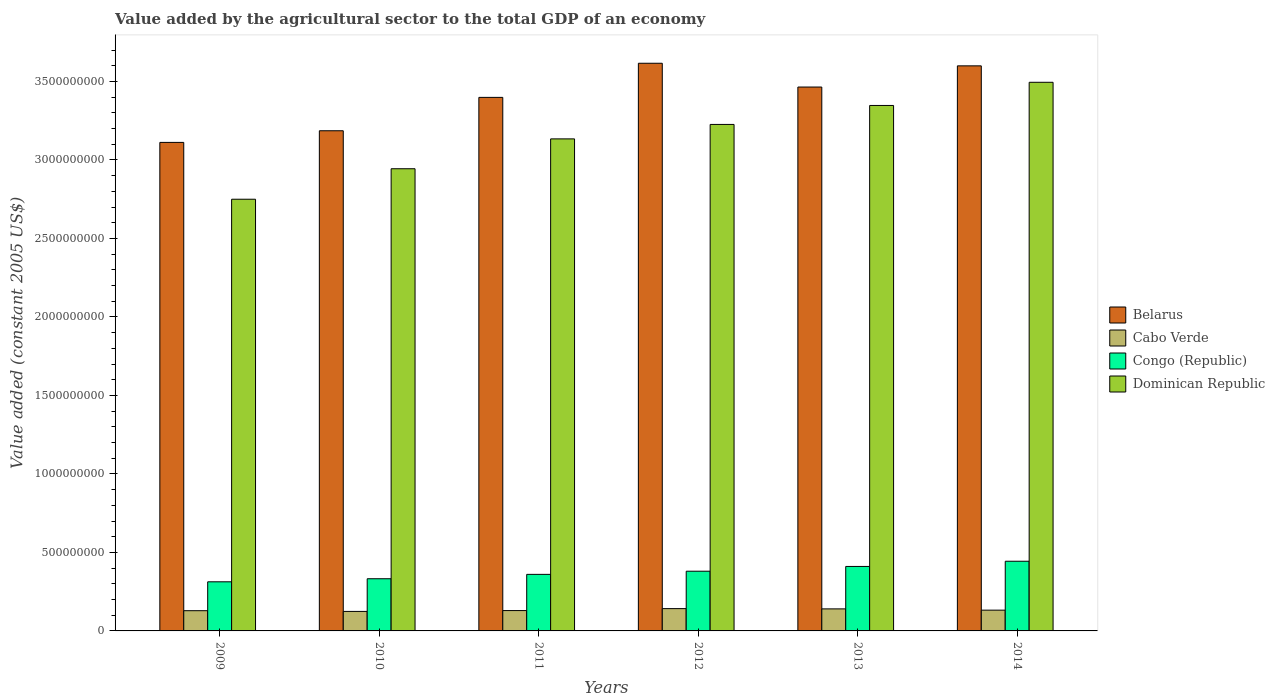How many different coloured bars are there?
Keep it short and to the point. 4. In how many cases, is the number of bars for a given year not equal to the number of legend labels?
Your response must be concise. 0. What is the value added by the agricultural sector in Congo (Republic) in 2010?
Ensure brevity in your answer.  3.32e+08. Across all years, what is the maximum value added by the agricultural sector in Congo (Republic)?
Provide a succinct answer. 4.44e+08. Across all years, what is the minimum value added by the agricultural sector in Belarus?
Your answer should be very brief. 3.11e+09. In which year was the value added by the agricultural sector in Dominican Republic minimum?
Your answer should be compact. 2009. What is the total value added by the agricultural sector in Congo (Republic) in the graph?
Provide a short and direct response. 2.24e+09. What is the difference between the value added by the agricultural sector in Belarus in 2012 and that in 2013?
Offer a terse response. 1.51e+08. What is the difference between the value added by the agricultural sector in Dominican Republic in 2010 and the value added by the agricultural sector in Congo (Republic) in 2013?
Your response must be concise. 2.53e+09. What is the average value added by the agricultural sector in Belarus per year?
Your answer should be compact. 3.40e+09. In the year 2011, what is the difference between the value added by the agricultural sector in Congo (Republic) and value added by the agricultural sector in Cabo Verde?
Ensure brevity in your answer.  2.31e+08. What is the ratio of the value added by the agricultural sector in Cabo Verde in 2012 to that in 2013?
Provide a succinct answer. 1.01. Is the value added by the agricultural sector in Dominican Republic in 2012 less than that in 2014?
Your answer should be compact. Yes. Is the difference between the value added by the agricultural sector in Congo (Republic) in 2011 and 2012 greater than the difference between the value added by the agricultural sector in Cabo Verde in 2011 and 2012?
Ensure brevity in your answer.  No. What is the difference between the highest and the second highest value added by the agricultural sector in Congo (Republic)?
Make the answer very short. 3.31e+07. What is the difference between the highest and the lowest value added by the agricultural sector in Belarus?
Give a very brief answer. 5.04e+08. In how many years, is the value added by the agricultural sector in Congo (Republic) greater than the average value added by the agricultural sector in Congo (Republic) taken over all years?
Provide a short and direct response. 3. Is the sum of the value added by the agricultural sector in Cabo Verde in 2011 and 2014 greater than the maximum value added by the agricultural sector in Congo (Republic) across all years?
Ensure brevity in your answer.  No. Is it the case that in every year, the sum of the value added by the agricultural sector in Cabo Verde and value added by the agricultural sector in Dominican Republic is greater than the sum of value added by the agricultural sector in Congo (Republic) and value added by the agricultural sector in Belarus?
Offer a very short reply. Yes. What does the 2nd bar from the left in 2014 represents?
Give a very brief answer. Cabo Verde. What does the 2nd bar from the right in 2010 represents?
Provide a short and direct response. Congo (Republic). Is it the case that in every year, the sum of the value added by the agricultural sector in Belarus and value added by the agricultural sector in Congo (Republic) is greater than the value added by the agricultural sector in Cabo Verde?
Your answer should be compact. Yes. How many years are there in the graph?
Provide a succinct answer. 6. Are the values on the major ticks of Y-axis written in scientific E-notation?
Provide a succinct answer. No. How many legend labels are there?
Your answer should be compact. 4. How are the legend labels stacked?
Offer a very short reply. Vertical. What is the title of the graph?
Provide a succinct answer. Value added by the agricultural sector to the total GDP of an economy. Does "Tanzania" appear as one of the legend labels in the graph?
Offer a very short reply. No. What is the label or title of the X-axis?
Keep it short and to the point. Years. What is the label or title of the Y-axis?
Your answer should be very brief. Value added (constant 2005 US$). What is the Value added (constant 2005 US$) in Belarus in 2009?
Your answer should be compact. 3.11e+09. What is the Value added (constant 2005 US$) in Cabo Verde in 2009?
Make the answer very short. 1.29e+08. What is the Value added (constant 2005 US$) in Congo (Republic) in 2009?
Keep it short and to the point. 3.13e+08. What is the Value added (constant 2005 US$) of Dominican Republic in 2009?
Ensure brevity in your answer.  2.75e+09. What is the Value added (constant 2005 US$) of Belarus in 2010?
Offer a very short reply. 3.19e+09. What is the Value added (constant 2005 US$) in Cabo Verde in 2010?
Offer a very short reply. 1.24e+08. What is the Value added (constant 2005 US$) of Congo (Republic) in 2010?
Ensure brevity in your answer.  3.32e+08. What is the Value added (constant 2005 US$) of Dominican Republic in 2010?
Provide a succinct answer. 2.94e+09. What is the Value added (constant 2005 US$) of Belarus in 2011?
Provide a succinct answer. 3.40e+09. What is the Value added (constant 2005 US$) of Cabo Verde in 2011?
Your answer should be very brief. 1.30e+08. What is the Value added (constant 2005 US$) in Congo (Republic) in 2011?
Keep it short and to the point. 3.60e+08. What is the Value added (constant 2005 US$) of Dominican Republic in 2011?
Your response must be concise. 3.13e+09. What is the Value added (constant 2005 US$) of Belarus in 2012?
Offer a very short reply. 3.62e+09. What is the Value added (constant 2005 US$) of Cabo Verde in 2012?
Your response must be concise. 1.42e+08. What is the Value added (constant 2005 US$) in Congo (Republic) in 2012?
Give a very brief answer. 3.80e+08. What is the Value added (constant 2005 US$) in Dominican Republic in 2012?
Your answer should be compact. 3.23e+09. What is the Value added (constant 2005 US$) of Belarus in 2013?
Offer a very short reply. 3.46e+09. What is the Value added (constant 2005 US$) in Cabo Verde in 2013?
Keep it short and to the point. 1.40e+08. What is the Value added (constant 2005 US$) in Congo (Republic) in 2013?
Offer a very short reply. 4.11e+08. What is the Value added (constant 2005 US$) of Dominican Republic in 2013?
Your answer should be very brief. 3.35e+09. What is the Value added (constant 2005 US$) in Belarus in 2014?
Make the answer very short. 3.60e+09. What is the Value added (constant 2005 US$) in Cabo Verde in 2014?
Keep it short and to the point. 1.32e+08. What is the Value added (constant 2005 US$) of Congo (Republic) in 2014?
Provide a short and direct response. 4.44e+08. What is the Value added (constant 2005 US$) in Dominican Republic in 2014?
Offer a terse response. 3.49e+09. Across all years, what is the maximum Value added (constant 2005 US$) of Belarus?
Ensure brevity in your answer.  3.62e+09. Across all years, what is the maximum Value added (constant 2005 US$) in Cabo Verde?
Your answer should be compact. 1.42e+08. Across all years, what is the maximum Value added (constant 2005 US$) in Congo (Republic)?
Make the answer very short. 4.44e+08. Across all years, what is the maximum Value added (constant 2005 US$) in Dominican Republic?
Your response must be concise. 3.49e+09. Across all years, what is the minimum Value added (constant 2005 US$) in Belarus?
Provide a succinct answer. 3.11e+09. Across all years, what is the minimum Value added (constant 2005 US$) of Cabo Verde?
Provide a short and direct response. 1.24e+08. Across all years, what is the minimum Value added (constant 2005 US$) in Congo (Republic)?
Make the answer very short. 3.13e+08. Across all years, what is the minimum Value added (constant 2005 US$) in Dominican Republic?
Your answer should be compact. 2.75e+09. What is the total Value added (constant 2005 US$) in Belarus in the graph?
Give a very brief answer. 2.04e+1. What is the total Value added (constant 2005 US$) in Cabo Verde in the graph?
Keep it short and to the point. 7.98e+08. What is the total Value added (constant 2005 US$) in Congo (Republic) in the graph?
Give a very brief answer. 2.24e+09. What is the total Value added (constant 2005 US$) in Dominican Republic in the graph?
Offer a terse response. 1.89e+1. What is the difference between the Value added (constant 2005 US$) of Belarus in 2009 and that in 2010?
Offer a very short reply. -7.41e+07. What is the difference between the Value added (constant 2005 US$) in Cabo Verde in 2009 and that in 2010?
Ensure brevity in your answer.  4.67e+06. What is the difference between the Value added (constant 2005 US$) in Congo (Republic) in 2009 and that in 2010?
Offer a very short reply. -1.96e+07. What is the difference between the Value added (constant 2005 US$) of Dominican Republic in 2009 and that in 2010?
Your answer should be compact. -1.94e+08. What is the difference between the Value added (constant 2005 US$) of Belarus in 2009 and that in 2011?
Offer a terse response. -2.87e+08. What is the difference between the Value added (constant 2005 US$) in Cabo Verde in 2009 and that in 2011?
Your answer should be compact. -7.68e+05. What is the difference between the Value added (constant 2005 US$) of Congo (Republic) in 2009 and that in 2011?
Make the answer very short. -4.75e+07. What is the difference between the Value added (constant 2005 US$) in Dominican Republic in 2009 and that in 2011?
Keep it short and to the point. -3.84e+08. What is the difference between the Value added (constant 2005 US$) of Belarus in 2009 and that in 2012?
Your answer should be very brief. -5.04e+08. What is the difference between the Value added (constant 2005 US$) of Cabo Verde in 2009 and that in 2012?
Provide a short and direct response. -1.32e+07. What is the difference between the Value added (constant 2005 US$) of Congo (Republic) in 2009 and that in 2012?
Offer a very short reply. -6.75e+07. What is the difference between the Value added (constant 2005 US$) of Dominican Republic in 2009 and that in 2012?
Offer a very short reply. -4.76e+08. What is the difference between the Value added (constant 2005 US$) of Belarus in 2009 and that in 2013?
Provide a succinct answer. -3.53e+08. What is the difference between the Value added (constant 2005 US$) in Cabo Verde in 2009 and that in 2013?
Make the answer very short. -1.15e+07. What is the difference between the Value added (constant 2005 US$) in Congo (Republic) in 2009 and that in 2013?
Offer a very short reply. -9.79e+07. What is the difference between the Value added (constant 2005 US$) of Dominican Republic in 2009 and that in 2013?
Your answer should be very brief. -5.97e+08. What is the difference between the Value added (constant 2005 US$) in Belarus in 2009 and that in 2014?
Ensure brevity in your answer.  -4.88e+08. What is the difference between the Value added (constant 2005 US$) of Cabo Verde in 2009 and that in 2014?
Offer a very short reply. -3.41e+06. What is the difference between the Value added (constant 2005 US$) of Congo (Republic) in 2009 and that in 2014?
Ensure brevity in your answer.  -1.31e+08. What is the difference between the Value added (constant 2005 US$) in Dominican Republic in 2009 and that in 2014?
Give a very brief answer. -7.45e+08. What is the difference between the Value added (constant 2005 US$) in Belarus in 2010 and that in 2011?
Provide a short and direct response. -2.13e+08. What is the difference between the Value added (constant 2005 US$) in Cabo Verde in 2010 and that in 2011?
Your response must be concise. -5.44e+06. What is the difference between the Value added (constant 2005 US$) in Congo (Republic) in 2010 and that in 2011?
Keep it short and to the point. -2.79e+07. What is the difference between the Value added (constant 2005 US$) of Dominican Republic in 2010 and that in 2011?
Provide a succinct answer. -1.90e+08. What is the difference between the Value added (constant 2005 US$) in Belarus in 2010 and that in 2012?
Give a very brief answer. -4.30e+08. What is the difference between the Value added (constant 2005 US$) of Cabo Verde in 2010 and that in 2012?
Provide a short and direct response. -1.79e+07. What is the difference between the Value added (constant 2005 US$) in Congo (Republic) in 2010 and that in 2012?
Offer a very short reply. -4.79e+07. What is the difference between the Value added (constant 2005 US$) in Dominican Republic in 2010 and that in 2012?
Provide a succinct answer. -2.82e+08. What is the difference between the Value added (constant 2005 US$) in Belarus in 2010 and that in 2013?
Your answer should be compact. -2.79e+08. What is the difference between the Value added (constant 2005 US$) of Cabo Verde in 2010 and that in 2013?
Your answer should be compact. -1.61e+07. What is the difference between the Value added (constant 2005 US$) in Congo (Republic) in 2010 and that in 2013?
Make the answer very short. -7.83e+07. What is the difference between the Value added (constant 2005 US$) in Dominican Republic in 2010 and that in 2013?
Keep it short and to the point. -4.03e+08. What is the difference between the Value added (constant 2005 US$) of Belarus in 2010 and that in 2014?
Offer a very short reply. -4.13e+08. What is the difference between the Value added (constant 2005 US$) in Cabo Verde in 2010 and that in 2014?
Your response must be concise. -8.08e+06. What is the difference between the Value added (constant 2005 US$) of Congo (Republic) in 2010 and that in 2014?
Give a very brief answer. -1.11e+08. What is the difference between the Value added (constant 2005 US$) of Dominican Republic in 2010 and that in 2014?
Provide a succinct answer. -5.51e+08. What is the difference between the Value added (constant 2005 US$) of Belarus in 2011 and that in 2012?
Make the answer very short. -2.17e+08. What is the difference between the Value added (constant 2005 US$) in Cabo Verde in 2011 and that in 2012?
Provide a short and direct response. -1.24e+07. What is the difference between the Value added (constant 2005 US$) in Congo (Republic) in 2011 and that in 2012?
Provide a short and direct response. -2.00e+07. What is the difference between the Value added (constant 2005 US$) in Dominican Republic in 2011 and that in 2012?
Ensure brevity in your answer.  -9.20e+07. What is the difference between the Value added (constant 2005 US$) in Belarus in 2011 and that in 2013?
Provide a succinct answer. -6.59e+07. What is the difference between the Value added (constant 2005 US$) of Cabo Verde in 2011 and that in 2013?
Give a very brief answer. -1.07e+07. What is the difference between the Value added (constant 2005 US$) in Congo (Republic) in 2011 and that in 2013?
Provide a succinct answer. -5.04e+07. What is the difference between the Value added (constant 2005 US$) of Dominican Republic in 2011 and that in 2013?
Provide a short and direct response. -2.13e+08. What is the difference between the Value added (constant 2005 US$) of Belarus in 2011 and that in 2014?
Ensure brevity in your answer.  -2.01e+08. What is the difference between the Value added (constant 2005 US$) of Cabo Verde in 2011 and that in 2014?
Your answer should be compact. -2.64e+06. What is the difference between the Value added (constant 2005 US$) in Congo (Republic) in 2011 and that in 2014?
Your answer should be compact. -8.36e+07. What is the difference between the Value added (constant 2005 US$) of Dominican Republic in 2011 and that in 2014?
Give a very brief answer. -3.60e+08. What is the difference between the Value added (constant 2005 US$) in Belarus in 2012 and that in 2013?
Ensure brevity in your answer.  1.51e+08. What is the difference between the Value added (constant 2005 US$) of Cabo Verde in 2012 and that in 2013?
Give a very brief answer. 1.72e+06. What is the difference between the Value added (constant 2005 US$) of Congo (Republic) in 2012 and that in 2013?
Give a very brief answer. -3.04e+07. What is the difference between the Value added (constant 2005 US$) of Dominican Republic in 2012 and that in 2013?
Offer a terse response. -1.21e+08. What is the difference between the Value added (constant 2005 US$) in Belarus in 2012 and that in 2014?
Offer a terse response. 1.66e+07. What is the difference between the Value added (constant 2005 US$) of Cabo Verde in 2012 and that in 2014?
Keep it short and to the point. 9.78e+06. What is the difference between the Value added (constant 2005 US$) of Congo (Republic) in 2012 and that in 2014?
Your answer should be compact. -6.35e+07. What is the difference between the Value added (constant 2005 US$) in Dominican Republic in 2012 and that in 2014?
Your response must be concise. -2.68e+08. What is the difference between the Value added (constant 2005 US$) in Belarus in 2013 and that in 2014?
Ensure brevity in your answer.  -1.35e+08. What is the difference between the Value added (constant 2005 US$) in Cabo Verde in 2013 and that in 2014?
Your answer should be compact. 8.06e+06. What is the difference between the Value added (constant 2005 US$) in Congo (Republic) in 2013 and that in 2014?
Your response must be concise. -3.31e+07. What is the difference between the Value added (constant 2005 US$) in Dominican Republic in 2013 and that in 2014?
Keep it short and to the point. -1.48e+08. What is the difference between the Value added (constant 2005 US$) in Belarus in 2009 and the Value added (constant 2005 US$) in Cabo Verde in 2010?
Offer a terse response. 2.99e+09. What is the difference between the Value added (constant 2005 US$) of Belarus in 2009 and the Value added (constant 2005 US$) of Congo (Republic) in 2010?
Keep it short and to the point. 2.78e+09. What is the difference between the Value added (constant 2005 US$) of Belarus in 2009 and the Value added (constant 2005 US$) of Dominican Republic in 2010?
Offer a very short reply. 1.68e+08. What is the difference between the Value added (constant 2005 US$) in Cabo Verde in 2009 and the Value added (constant 2005 US$) in Congo (Republic) in 2010?
Provide a short and direct response. -2.04e+08. What is the difference between the Value added (constant 2005 US$) in Cabo Verde in 2009 and the Value added (constant 2005 US$) in Dominican Republic in 2010?
Give a very brief answer. -2.82e+09. What is the difference between the Value added (constant 2005 US$) in Congo (Republic) in 2009 and the Value added (constant 2005 US$) in Dominican Republic in 2010?
Ensure brevity in your answer.  -2.63e+09. What is the difference between the Value added (constant 2005 US$) of Belarus in 2009 and the Value added (constant 2005 US$) of Cabo Verde in 2011?
Offer a terse response. 2.98e+09. What is the difference between the Value added (constant 2005 US$) of Belarus in 2009 and the Value added (constant 2005 US$) of Congo (Republic) in 2011?
Make the answer very short. 2.75e+09. What is the difference between the Value added (constant 2005 US$) of Belarus in 2009 and the Value added (constant 2005 US$) of Dominican Republic in 2011?
Your answer should be very brief. -2.24e+07. What is the difference between the Value added (constant 2005 US$) of Cabo Verde in 2009 and the Value added (constant 2005 US$) of Congo (Republic) in 2011?
Provide a short and direct response. -2.31e+08. What is the difference between the Value added (constant 2005 US$) in Cabo Verde in 2009 and the Value added (constant 2005 US$) in Dominican Republic in 2011?
Keep it short and to the point. -3.01e+09. What is the difference between the Value added (constant 2005 US$) in Congo (Republic) in 2009 and the Value added (constant 2005 US$) in Dominican Republic in 2011?
Ensure brevity in your answer.  -2.82e+09. What is the difference between the Value added (constant 2005 US$) in Belarus in 2009 and the Value added (constant 2005 US$) in Cabo Verde in 2012?
Your response must be concise. 2.97e+09. What is the difference between the Value added (constant 2005 US$) in Belarus in 2009 and the Value added (constant 2005 US$) in Congo (Republic) in 2012?
Give a very brief answer. 2.73e+09. What is the difference between the Value added (constant 2005 US$) in Belarus in 2009 and the Value added (constant 2005 US$) in Dominican Republic in 2012?
Your answer should be compact. -1.14e+08. What is the difference between the Value added (constant 2005 US$) of Cabo Verde in 2009 and the Value added (constant 2005 US$) of Congo (Republic) in 2012?
Your answer should be compact. -2.51e+08. What is the difference between the Value added (constant 2005 US$) of Cabo Verde in 2009 and the Value added (constant 2005 US$) of Dominican Republic in 2012?
Provide a short and direct response. -3.10e+09. What is the difference between the Value added (constant 2005 US$) of Congo (Republic) in 2009 and the Value added (constant 2005 US$) of Dominican Republic in 2012?
Ensure brevity in your answer.  -2.91e+09. What is the difference between the Value added (constant 2005 US$) in Belarus in 2009 and the Value added (constant 2005 US$) in Cabo Verde in 2013?
Provide a succinct answer. 2.97e+09. What is the difference between the Value added (constant 2005 US$) of Belarus in 2009 and the Value added (constant 2005 US$) of Congo (Republic) in 2013?
Make the answer very short. 2.70e+09. What is the difference between the Value added (constant 2005 US$) of Belarus in 2009 and the Value added (constant 2005 US$) of Dominican Republic in 2013?
Offer a terse response. -2.35e+08. What is the difference between the Value added (constant 2005 US$) of Cabo Verde in 2009 and the Value added (constant 2005 US$) of Congo (Republic) in 2013?
Your answer should be compact. -2.82e+08. What is the difference between the Value added (constant 2005 US$) in Cabo Verde in 2009 and the Value added (constant 2005 US$) in Dominican Republic in 2013?
Ensure brevity in your answer.  -3.22e+09. What is the difference between the Value added (constant 2005 US$) of Congo (Republic) in 2009 and the Value added (constant 2005 US$) of Dominican Republic in 2013?
Offer a very short reply. -3.03e+09. What is the difference between the Value added (constant 2005 US$) in Belarus in 2009 and the Value added (constant 2005 US$) in Cabo Verde in 2014?
Give a very brief answer. 2.98e+09. What is the difference between the Value added (constant 2005 US$) of Belarus in 2009 and the Value added (constant 2005 US$) of Congo (Republic) in 2014?
Provide a succinct answer. 2.67e+09. What is the difference between the Value added (constant 2005 US$) of Belarus in 2009 and the Value added (constant 2005 US$) of Dominican Republic in 2014?
Provide a short and direct response. -3.83e+08. What is the difference between the Value added (constant 2005 US$) of Cabo Verde in 2009 and the Value added (constant 2005 US$) of Congo (Republic) in 2014?
Keep it short and to the point. -3.15e+08. What is the difference between the Value added (constant 2005 US$) in Cabo Verde in 2009 and the Value added (constant 2005 US$) in Dominican Republic in 2014?
Your answer should be compact. -3.37e+09. What is the difference between the Value added (constant 2005 US$) in Congo (Republic) in 2009 and the Value added (constant 2005 US$) in Dominican Republic in 2014?
Offer a very short reply. -3.18e+09. What is the difference between the Value added (constant 2005 US$) in Belarus in 2010 and the Value added (constant 2005 US$) in Cabo Verde in 2011?
Keep it short and to the point. 3.06e+09. What is the difference between the Value added (constant 2005 US$) in Belarus in 2010 and the Value added (constant 2005 US$) in Congo (Republic) in 2011?
Your answer should be very brief. 2.83e+09. What is the difference between the Value added (constant 2005 US$) in Belarus in 2010 and the Value added (constant 2005 US$) in Dominican Republic in 2011?
Your answer should be very brief. 5.17e+07. What is the difference between the Value added (constant 2005 US$) of Cabo Verde in 2010 and the Value added (constant 2005 US$) of Congo (Republic) in 2011?
Offer a terse response. -2.36e+08. What is the difference between the Value added (constant 2005 US$) of Cabo Verde in 2010 and the Value added (constant 2005 US$) of Dominican Republic in 2011?
Make the answer very short. -3.01e+09. What is the difference between the Value added (constant 2005 US$) of Congo (Republic) in 2010 and the Value added (constant 2005 US$) of Dominican Republic in 2011?
Your response must be concise. -2.80e+09. What is the difference between the Value added (constant 2005 US$) in Belarus in 2010 and the Value added (constant 2005 US$) in Cabo Verde in 2012?
Ensure brevity in your answer.  3.04e+09. What is the difference between the Value added (constant 2005 US$) in Belarus in 2010 and the Value added (constant 2005 US$) in Congo (Republic) in 2012?
Keep it short and to the point. 2.81e+09. What is the difference between the Value added (constant 2005 US$) of Belarus in 2010 and the Value added (constant 2005 US$) of Dominican Republic in 2012?
Provide a short and direct response. -4.03e+07. What is the difference between the Value added (constant 2005 US$) of Cabo Verde in 2010 and the Value added (constant 2005 US$) of Congo (Republic) in 2012?
Make the answer very short. -2.56e+08. What is the difference between the Value added (constant 2005 US$) of Cabo Verde in 2010 and the Value added (constant 2005 US$) of Dominican Republic in 2012?
Ensure brevity in your answer.  -3.10e+09. What is the difference between the Value added (constant 2005 US$) in Congo (Republic) in 2010 and the Value added (constant 2005 US$) in Dominican Republic in 2012?
Your answer should be compact. -2.89e+09. What is the difference between the Value added (constant 2005 US$) in Belarus in 2010 and the Value added (constant 2005 US$) in Cabo Verde in 2013?
Your response must be concise. 3.05e+09. What is the difference between the Value added (constant 2005 US$) in Belarus in 2010 and the Value added (constant 2005 US$) in Congo (Republic) in 2013?
Offer a terse response. 2.78e+09. What is the difference between the Value added (constant 2005 US$) of Belarus in 2010 and the Value added (constant 2005 US$) of Dominican Republic in 2013?
Provide a succinct answer. -1.61e+08. What is the difference between the Value added (constant 2005 US$) of Cabo Verde in 2010 and the Value added (constant 2005 US$) of Congo (Republic) in 2013?
Offer a very short reply. -2.87e+08. What is the difference between the Value added (constant 2005 US$) in Cabo Verde in 2010 and the Value added (constant 2005 US$) in Dominican Republic in 2013?
Your answer should be compact. -3.22e+09. What is the difference between the Value added (constant 2005 US$) in Congo (Republic) in 2010 and the Value added (constant 2005 US$) in Dominican Republic in 2013?
Your response must be concise. -3.01e+09. What is the difference between the Value added (constant 2005 US$) of Belarus in 2010 and the Value added (constant 2005 US$) of Cabo Verde in 2014?
Keep it short and to the point. 3.05e+09. What is the difference between the Value added (constant 2005 US$) of Belarus in 2010 and the Value added (constant 2005 US$) of Congo (Republic) in 2014?
Your answer should be very brief. 2.74e+09. What is the difference between the Value added (constant 2005 US$) of Belarus in 2010 and the Value added (constant 2005 US$) of Dominican Republic in 2014?
Your response must be concise. -3.09e+08. What is the difference between the Value added (constant 2005 US$) in Cabo Verde in 2010 and the Value added (constant 2005 US$) in Congo (Republic) in 2014?
Your answer should be compact. -3.20e+08. What is the difference between the Value added (constant 2005 US$) of Cabo Verde in 2010 and the Value added (constant 2005 US$) of Dominican Republic in 2014?
Your answer should be very brief. -3.37e+09. What is the difference between the Value added (constant 2005 US$) in Congo (Republic) in 2010 and the Value added (constant 2005 US$) in Dominican Republic in 2014?
Your response must be concise. -3.16e+09. What is the difference between the Value added (constant 2005 US$) in Belarus in 2011 and the Value added (constant 2005 US$) in Cabo Verde in 2012?
Your response must be concise. 3.26e+09. What is the difference between the Value added (constant 2005 US$) of Belarus in 2011 and the Value added (constant 2005 US$) of Congo (Republic) in 2012?
Your response must be concise. 3.02e+09. What is the difference between the Value added (constant 2005 US$) in Belarus in 2011 and the Value added (constant 2005 US$) in Dominican Republic in 2012?
Ensure brevity in your answer.  1.72e+08. What is the difference between the Value added (constant 2005 US$) in Cabo Verde in 2011 and the Value added (constant 2005 US$) in Congo (Republic) in 2012?
Ensure brevity in your answer.  -2.51e+08. What is the difference between the Value added (constant 2005 US$) in Cabo Verde in 2011 and the Value added (constant 2005 US$) in Dominican Republic in 2012?
Make the answer very short. -3.10e+09. What is the difference between the Value added (constant 2005 US$) in Congo (Republic) in 2011 and the Value added (constant 2005 US$) in Dominican Republic in 2012?
Provide a succinct answer. -2.87e+09. What is the difference between the Value added (constant 2005 US$) in Belarus in 2011 and the Value added (constant 2005 US$) in Cabo Verde in 2013?
Provide a succinct answer. 3.26e+09. What is the difference between the Value added (constant 2005 US$) of Belarus in 2011 and the Value added (constant 2005 US$) of Congo (Republic) in 2013?
Provide a short and direct response. 2.99e+09. What is the difference between the Value added (constant 2005 US$) in Belarus in 2011 and the Value added (constant 2005 US$) in Dominican Republic in 2013?
Make the answer very short. 5.15e+07. What is the difference between the Value added (constant 2005 US$) in Cabo Verde in 2011 and the Value added (constant 2005 US$) in Congo (Republic) in 2013?
Your answer should be very brief. -2.81e+08. What is the difference between the Value added (constant 2005 US$) of Cabo Verde in 2011 and the Value added (constant 2005 US$) of Dominican Republic in 2013?
Keep it short and to the point. -3.22e+09. What is the difference between the Value added (constant 2005 US$) of Congo (Republic) in 2011 and the Value added (constant 2005 US$) of Dominican Republic in 2013?
Provide a succinct answer. -2.99e+09. What is the difference between the Value added (constant 2005 US$) in Belarus in 2011 and the Value added (constant 2005 US$) in Cabo Verde in 2014?
Your response must be concise. 3.27e+09. What is the difference between the Value added (constant 2005 US$) in Belarus in 2011 and the Value added (constant 2005 US$) in Congo (Republic) in 2014?
Ensure brevity in your answer.  2.95e+09. What is the difference between the Value added (constant 2005 US$) of Belarus in 2011 and the Value added (constant 2005 US$) of Dominican Republic in 2014?
Your answer should be very brief. -9.61e+07. What is the difference between the Value added (constant 2005 US$) in Cabo Verde in 2011 and the Value added (constant 2005 US$) in Congo (Republic) in 2014?
Provide a succinct answer. -3.14e+08. What is the difference between the Value added (constant 2005 US$) of Cabo Verde in 2011 and the Value added (constant 2005 US$) of Dominican Republic in 2014?
Provide a short and direct response. -3.37e+09. What is the difference between the Value added (constant 2005 US$) in Congo (Republic) in 2011 and the Value added (constant 2005 US$) in Dominican Republic in 2014?
Your response must be concise. -3.13e+09. What is the difference between the Value added (constant 2005 US$) in Belarus in 2012 and the Value added (constant 2005 US$) in Cabo Verde in 2013?
Offer a terse response. 3.48e+09. What is the difference between the Value added (constant 2005 US$) of Belarus in 2012 and the Value added (constant 2005 US$) of Congo (Republic) in 2013?
Your answer should be compact. 3.21e+09. What is the difference between the Value added (constant 2005 US$) of Belarus in 2012 and the Value added (constant 2005 US$) of Dominican Republic in 2013?
Your response must be concise. 2.69e+08. What is the difference between the Value added (constant 2005 US$) of Cabo Verde in 2012 and the Value added (constant 2005 US$) of Congo (Republic) in 2013?
Provide a succinct answer. -2.69e+08. What is the difference between the Value added (constant 2005 US$) of Cabo Verde in 2012 and the Value added (constant 2005 US$) of Dominican Republic in 2013?
Make the answer very short. -3.21e+09. What is the difference between the Value added (constant 2005 US$) in Congo (Republic) in 2012 and the Value added (constant 2005 US$) in Dominican Republic in 2013?
Give a very brief answer. -2.97e+09. What is the difference between the Value added (constant 2005 US$) in Belarus in 2012 and the Value added (constant 2005 US$) in Cabo Verde in 2014?
Your answer should be very brief. 3.48e+09. What is the difference between the Value added (constant 2005 US$) of Belarus in 2012 and the Value added (constant 2005 US$) of Congo (Republic) in 2014?
Your answer should be compact. 3.17e+09. What is the difference between the Value added (constant 2005 US$) of Belarus in 2012 and the Value added (constant 2005 US$) of Dominican Republic in 2014?
Your response must be concise. 1.21e+08. What is the difference between the Value added (constant 2005 US$) of Cabo Verde in 2012 and the Value added (constant 2005 US$) of Congo (Republic) in 2014?
Your answer should be compact. -3.02e+08. What is the difference between the Value added (constant 2005 US$) in Cabo Verde in 2012 and the Value added (constant 2005 US$) in Dominican Republic in 2014?
Your answer should be compact. -3.35e+09. What is the difference between the Value added (constant 2005 US$) of Congo (Republic) in 2012 and the Value added (constant 2005 US$) of Dominican Republic in 2014?
Your answer should be compact. -3.11e+09. What is the difference between the Value added (constant 2005 US$) in Belarus in 2013 and the Value added (constant 2005 US$) in Cabo Verde in 2014?
Provide a short and direct response. 3.33e+09. What is the difference between the Value added (constant 2005 US$) in Belarus in 2013 and the Value added (constant 2005 US$) in Congo (Republic) in 2014?
Provide a succinct answer. 3.02e+09. What is the difference between the Value added (constant 2005 US$) of Belarus in 2013 and the Value added (constant 2005 US$) of Dominican Republic in 2014?
Offer a terse response. -3.02e+07. What is the difference between the Value added (constant 2005 US$) of Cabo Verde in 2013 and the Value added (constant 2005 US$) of Congo (Republic) in 2014?
Provide a succinct answer. -3.04e+08. What is the difference between the Value added (constant 2005 US$) in Cabo Verde in 2013 and the Value added (constant 2005 US$) in Dominican Republic in 2014?
Make the answer very short. -3.35e+09. What is the difference between the Value added (constant 2005 US$) of Congo (Republic) in 2013 and the Value added (constant 2005 US$) of Dominican Republic in 2014?
Keep it short and to the point. -3.08e+09. What is the average Value added (constant 2005 US$) of Belarus per year?
Your response must be concise. 3.40e+09. What is the average Value added (constant 2005 US$) in Cabo Verde per year?
Your answer should be compact. 1.33e+08. What is the average Value added (constant 2005 US$) of Congo (Republic) per year?
Make the answer very short. 3.73e+08. What is the average Value added (constant 2005 US$) in Dominican Republic per year?
Make the answer very short. 3.15e+09. In the year 2009, what is the difference between the Value added (constant 2005 US$) in Belarus and Value added (constant 2005 US$) in Cabo Verde?
Offer a very short reply. 2.98e+09. In the year 2009, what is the difference between the Value added (constant 2005 US$) of Belarus and Value added (constant 2005 US$) of Congo (Republic)?
Provide a succinct answer. 2.80e+09. In the year 2009, what is the difference between the Value added (constant 2005 US$) in Belarus and Value added (constant 2005 US$) in Dominican Republic?
Make the answer very short. 3.62e+08. In the year 2009, what is the difference between the Value added (constant 2005 US$) in Cabo Verde and Value added (constant 2005 US$) in Congo (Republic)?
Offer a very short reply. -1.84e+08. In the year 2009, what is the difference between the Value added (constant 2005 US$) in Cabo Verde and Value added (constant 2005 US$) in Dominican Republic?
Provide a short and direct response. -2.62e+09. In the year 2009, what is the difference between the Value added (constant 2005 US$) of Congo (Republic) and Value added (constant 2005 US$) of Dominican Republic?
Your answer should be very brief. -2.44e+09. In the year 2010, what is the difference between the Value added (constant 2005 US$) of Belarus and Value added (constant 2005 US$) of Cabo Verde?
Offer a terse response. 3.06e+09. In the year 2010, what is the difference between the Value added (constant 2005 US$) in Belarus and Value added (constant 2005 US$) in Congo (Republic)?
Give a very brief answer. 2.85e+09. In the year 2010, what is the difference between the Value added (constant 2005 US$) of Belarus and Value added (constant 2005 US$) of Dominican Republic?
Your answer should be compact. 2.42e+08. In the year 2010, what is the difference between the Value added (constant 2005 US$) in Cabo Verde and Value added (constant 2005 US$) in Congo (Republic)?
Make the answer very short. -2.08e+08. In the year 2010, what is the difference between the Value added (constant 2005 US$) in Cabo Verde and Value added (constant 2005 US$) in Dominican Republic?
Give a very brief answer. -2.82e+09. In the year 2010, what is the difference between the Value added (constant 2005 US$) in Congo (Republic) and Value added (constant 2005 US$) in Dominican Republic?
Your answer should be compact. -2.61e+09. In the year 2011, what is the difference between the Value added (constant 2005 US$) of Belarus and Value added (constant 2005 US$) of Cabo Verde?
Provide a short and direct response. 3.27e+09. In the year 2011, what is the difference between the Value added (constant 2005 US$) in Belarus and Value added (constant 2005 US$) in Congo (Republic)?
Provide a short and direct response. 3.04e+09. In the year 2011, what is the difference between the Value added (constant 2005 US$) of Belarus and Value added (constant 2005 US$) of Dominican Republic?
Make the answer very short. 2.64e+08. In the year 2011, what is the difference between the Value added (constant 2005 US$) of Cabo Verde and Value added (constant 2005 US$) of Congo (Republic)?
Give a very brief answer. -2.31e+08. In the year 2011, what is the difference between the Value added (constant 2005 US$) of Cabo Verde and Value added (constant 2005 US$) of Dominican Republic?
Give a very brief answer. -3.00e+09. In the year 2011, what is the difference between the Value added (constant 2005 US$) of Congo (Republic) and Value added (constant 2005 US$) of Dominican Republic?
Provide a succinct answer. -2.77e+09. In the year 2012, what is the difference between the Value added (constant 2005 US$) in Belarus and Value added (constant 2005 US$) in Cabo Verde?
Ensure brevity in your answer.  3.47e+09. In the year 2012, what is the difference between the Value added (constant 2005 US$) of Belarus and Value added (constant 2005 US$) of Congo (Republic)?
Your answer should be compact. 3.24e+09. In the year 2012, what is the difference between the Value added (constant 2005 US$) in Belarus and Value added (constant 2005 US$) in Dominican Republic?
Your answer should be compact. 3.90e+08. In the year 2012, what is the difference between the Value added (constant 2005 US$) of Cabo Verde and Value added (constant 2005 US$) of Congo (Republic)?
Provide a succinct answer. -2.38e+08. In the year 2012, what is the difference between the Value added (constant 2005 US$) in Cabo Verde and Value added (constant 2005 US$) in Dominican Republic?
Give a very brief answer. -3.08e+09. In the year 2012, what is the difference between the Value added (constant 2005 US$) in Congo (Republic) and Value added (constant 2005 US$) in Dominican Republic?
Provide a short and direct response. -2.85e+09. In the year 2013, what is the difference between the Value added (constant 2005 US$) in Belarus and Value added (constant 2005 US$) in Cabo Verde?
Your answer should be compact. 3.32e+09. In the year 2013, what is the difference between the Value added (constant 2005 US$) of Belarus and Value added (constant 2005 US$) of Congo (Republic)?
Your response must be concise. 3.05e+09. In the year 2013, what is the difference between the Value added (constant 2005 US$) of Belarus and Value added (constant 2005 US$) of Dominican Republic?
Make the answer very short. 1.17e+08. In the year 2013, what is the difference between the Value added (constant 2005 US$) in Cabo Verde and Value added (constant 2005 US$) in Congo (Republic)?
Offer a very short reply. -2.70e+08. In the year 2013, what is the difference between the Value added (constant 2005 US$) in Cabo Verde and Value added (constant 2005 US$) in Dominican Republic?
Your answer should be very brief. -3.21e+09. In the year 2013, what is the difference between the Value added (constant 2005 US$) of Congo (Republic) and Value added (constant 2005 US$) of Dominican Republic?
Your answer should be compact. -2.94e+09. In the year 2014, what is the difference between the Value added (constant 2005 US$) in Belarus and Value added (constant 2005 US$) in Cabo Verde?
Keep it short and to the point. 3.47e+09. In the year 2014, what is the difference between the Value added (constant 2005 US$) in Belarus and Value added (constant 2005 US$) in Congo (Republic)?
Keep it short and to the point. 3.16e+09. In the year 2014, what is the difference between the Value added (constant 2005 US$) in Belarus and Value added (constant 2005 US$) in Dominican Republic?
Keep it short and to the point. 1.05e+08. In the year 2014, what is the difference between the Value added (constant 2005 US$) in Cabo Verde and Value added (constant 2005 US$) in Congo (Republic)?
Ensure brevity in your answer.  -3.12e+08. In the year 2014, what is the difference between the Value added (constant 2005 US$) in Cabo Verde and Value added (constant 2005 US$) in Dominican Republic?
Your answer should be compact. -3.36e+09. In the year 2014, what is the difference between the Value added (constant 2005 US$) in Congo (Republic) and Value added (constant 2005 US$) in Dominican Republic?
Ensure brevity in your answer.  -3.05e+09. What is the ratio of the Value added (constant 2005 US$) in Belarus in 2009 to that in 2010?
Your answer should be very brief. 0.98. What is the ratio of the Value added (constant 2005 US$) of Cabo Verde in 2009 to that in 2010?
Your response must be concise. 1.04. What is the ratio of the Value added (constant 2005 US$) of Congo (Republic) in 2009 to that in 2010?
Provide a succinct answer. 0.94. What is the ratio of the Value added (constant 2005 US$) of Dominican Republic in 2009 to that in 2010?
Keep it short and to the point. 0.93. What is the ratio of the Value added (constant 2005 US$) in Belarus in 2009 to that in 2011?
Make the answer very short. 0.92. What is the ratio of the Value added (constant 2005 US$) of Cabo Verde in 2009 to that in 2011?
Offer a terse response. 0.99. What is the ratio of the Value added (constant 2005 US$) in Congo (Republic) in 2009 to that in 2011?
Provide a succinct answer. 0.87. What is the ratio of the Value added (constant 2005 US$) in Dominican Republic in 2009 to that in 2011?
Provide a succinct answer. 0.88. What is the ratio of the Value added (constant 2005 US$) of Belarus in 2009 to that in 2012?
Your answer should be very brief. 0.86. What is the ratio of the Value added (constant 2005 US$) in Cabo Verde in 2009 to that in 2012?
Keep it short and to the point. 0.91. What is the ratio of the Value added (constant 2005 US$) in Congo (Republic) in 2009 to that in 2012?
Provide a short and direct response. 0.82. What is the ratio of the Value added (constant 2005 US$) in Dominican Republic in 2009 to that in 2012?
Make the answer very short. 0.85. What is the ratio of the Value added (constant 2005 US$) in Belarus in 2009 to that in 2013?
Provide a succinct answer. 0.9. What is the ratio of the Value added (constant 2005 US$) of Cabo Verde in 2009 to that in 2013?
Give a very brief answer. 0.92. What is the ratio of the Value added (constant 2005 US$) of Congo (Republic) in 2009 to that in 2013?
Your response must be concise. 0.76. What is the ratio of the Value added (constant 2005 US$) of Dominican Republic in 2009 to that in 2013?
Ensure brevity in your answer.  0.82. What is the ratio of the Value added (constant 2005 US$) of Belarus in 2009 to that in 2014?
Offer a terse response. 0.86. What is the ratio of the Value added (constant 2005 US$) of Cabo Verde in 2009 to that in 2014?
Your answer should be very brief. 0.97. What is the ratio of the Value added (constant 2005 US$) of Congo (Republic) in 2009 to that in 2014?
Provide a short and direct response. 0.7. What is the ratio of the Value added (constant 2005 US$) in Dominican Republic in 2009 to that in 2014?
Provide a short and direct response. 0.79. What is the ratio of the Value added (constant 2005 US$) of Belarus in 2010 to that in 2011?
Your response must be concise. 0.94. What is the ratio of the Value added (constant 2005 US$) of Cabo Verde in 2010 to that in 2011?
Make the answer very short. 0.96. What is the ratio of the Value added (constant 2005 US$) of Congo (Republic) in 2010 to that in 2011?
Your answer should be very brief. 0.92. What is the ratio of the Value added (constant 2005 US$) of Dominican Republic in 2010 to that in 2011?
Your answer should be very brief. 0.94. What is the ratio of the Value added (constant 2005 US$) in Belarus in 2010 to that in 2012?
Give a very brief answer. 0.88. What is the ratio of the Value added (constant 2005 US$) in Cabo Verde in 2010 to that in 2012?
Keep it short and to the point. 0.87. What is the ratio of the Value added (constant 2005 US$) of Congo (Republic) in 2010 to that in 2012?
Offer a very short reply. 0.87. What is the ratio of the Value added (constant 2005 US$) of Dominican Republic in 2010 to that in 2012?
Provide a succinct answer. 0.91. What is the ratio of the Value added (constant 2005 US$) in Belarus in 2010 to that in 2013?
Your response must be concise. 0.92. What is the ratio of the Value added (constant 2005 US$) in Cabo Verde in 2010 to that in 2013?
Your answer should be compact. 0.89. What is the ratio of the Value added (constant 2005 US$) of Congo (Republic) in 2010 to that in 2013?
Offer a very short reply. 0.81. What is the ratio of the Value added (constant 2005 US$) in Dominican Republic in 2010 to that in 2013?
Offer a very short reply. 0.88. What is the ratio of the Value added (constant 2005 US$) of Belarus in 2010 to that in 2014?
Provide a succinct answer. 0.89. What is the ratio of the Value added (constant 2005 US$) in Cabo Verde in 2010 to that in 2014?
Keep it short and to the point. 0.94. What is the ratio of the Value added (constant 2005 US$) in Congo (Republic) in 2010 to that in 2014?
Provide a short and direct response. 0.75. What is the ratio of the Value added (constant 2005 US$) of Dominican Republic in 2010 to that in 2014?
Offer a very short reply. 0.84. What is the ratio of the Value added (constant 2005 US$) of Belarus in 2011 to that in 2012?
Ensure brevity in your answer.  0.94. What is the ratio of the Value added (constant 2005 US$) in Cabo Verde in 2011 to that in 2012?
Ensure brevity in your answer.  0.91. What is the ratio of the Value added (constant 2005 US$) in Congo (Republic) in 2011 to that in 2012?
Give a very brief answer. 0.95. What is the ratio of the Value added (constant 2005 US$) in Dominican Republic in 2011 to that in 2012?
Keep it short and to the point. 0.97. What is the ratio of the Value added (constant 2005 US$) of Cabo Verde in 2011 to that in 2013?
Ensure brevity in your answer.  0.92. What is the ratio of the Value added (constant 2005 US$) of Congo (Republic) in 2011 to that in 2013?
Make the answer very short. 0.88. What is the ratio of the Value added (constant 2005 US$) in Dominican Republic in 2011 to that in 2013?
Ensure brevity in your answer.  0.94. What is the ratio of the Value added (constant 2005 US$) of Belarus in 2011 to that in 2014?
Give a very brief answer. 0.94. What is the ratio of the Value added (constant 2005 US$) of Congo (Republic) in 2011 to that in 2014?
Ensure brevity in your answer.  0.81. What is the ratio of the Value added (constant 2005 US$) of Dominican Republic in 2011 to that in 2014?
Give a very brief answer. 0.9. What is the ratio of the Value added (constant 2005 US$) in Belarus in 2012 to that in 2013?
Your response must be concise. 1.04. What is the ratio of the Value added (constant 2005 US$) in Cabo Verde in 2012 to that in 2013?
Give a very brief answer. 1.01. What is the ratio of the Value added (constant 2005 US$) in Congo (Republic) in 2012 to that in 2013?
Provide a succinct answer. 0.93. What is the ratio of the Value added (constant 2005 US$) in Dominican Republic in 2012 to that in 2013?
Your response must be concise. 0.96. What is the ratio of the Value added (constant 2005 US$) of Cabo Verde in 2012 to that in 2014?
Make the answer very short. 1.07. What is the ratio of the Value added (constant 2005 US$) in Congo (Republic) in 2012 to that in 2014?
Your answer should be compact. 0.86. What is the ratio of the Value added (constant 2005 US$) in Dominican Republic in 2012 to that in 2014?
Make the answer very short. 0.92. What is the ratio of the Value added (constant 2005 US$) in Belarus in 2013 to that in 2014?
Your answer should be very brief. 0.96. What is the ratio of the Value added (constant 2005 US$) in Cabo Verde in 2013 to that in 2014?
Make the answer very short. 1.06. What is the ratio of the Value added (constant 2005 US$) in Congo (Republic) in 2013 to that in 2014?
Provide a short and direct response. 0.93. What is the ratio of the Value added (constant 2005 US$) in Dominican Republic in 2013 to that in 2014?
Provide a short and direct response. 0.96. What is the difference between the highest and the second highest Value added (constant 2005 US$) of Belarus?
Keep it short and to the point. 1.66e+07. What is the difference between the highest and the second highest Value added (constant 2005 US$) in Cabo Verde?
Your answer should be very brief. 1.72e+06. What is the difference between the highest and the second highest Value added (constant 2005 US$) of Congo (Republic)?
Your response must be concise. 3.31e+07. What is the difference between the highest and the second highest Value added (constant 2005 US$) in Dominican Republic?
Give a very brief answer. 1.48e+08. What is the difference between the highest and the lowest Value added (constant 2005 US$) in Belarus?
Your response must be concise. 5.04e+08. What is the difference between the highest and the lowest Value added (constant 2005 US$) in Cabo Verde?
Keep it short and to the point. 1.79e+07. What is the difference between the highest and the lowest Value added (constant 2005 US$) of Congo (Republic)?
Provide a succinct answer. 1.31e+08. What is the difference between the highest and the lowest Value added (constant 2005 US$) of Dominican Republic?
Make the answer very short. 7.45e+08. 